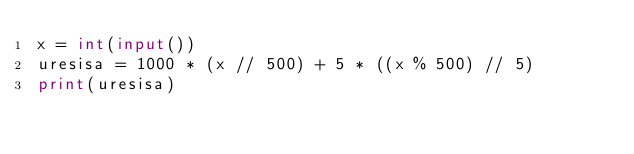Convert code to text. <code><loc_0><loc_0><loc_500><loc_500><_Python_>x = int(input())
uresisa = 1000 * (x // 500) + 5 * ((x % 500) // 5)
print(uresisa)</code> 